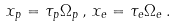<formula> <loc_0><loc_0><loc_500><loc_500>x _ { p } = \tau _ { p } \Omega _ { p } \, , \, x _ { e } = \tau _ { e } \Omega _ { e } \, .</formula> 